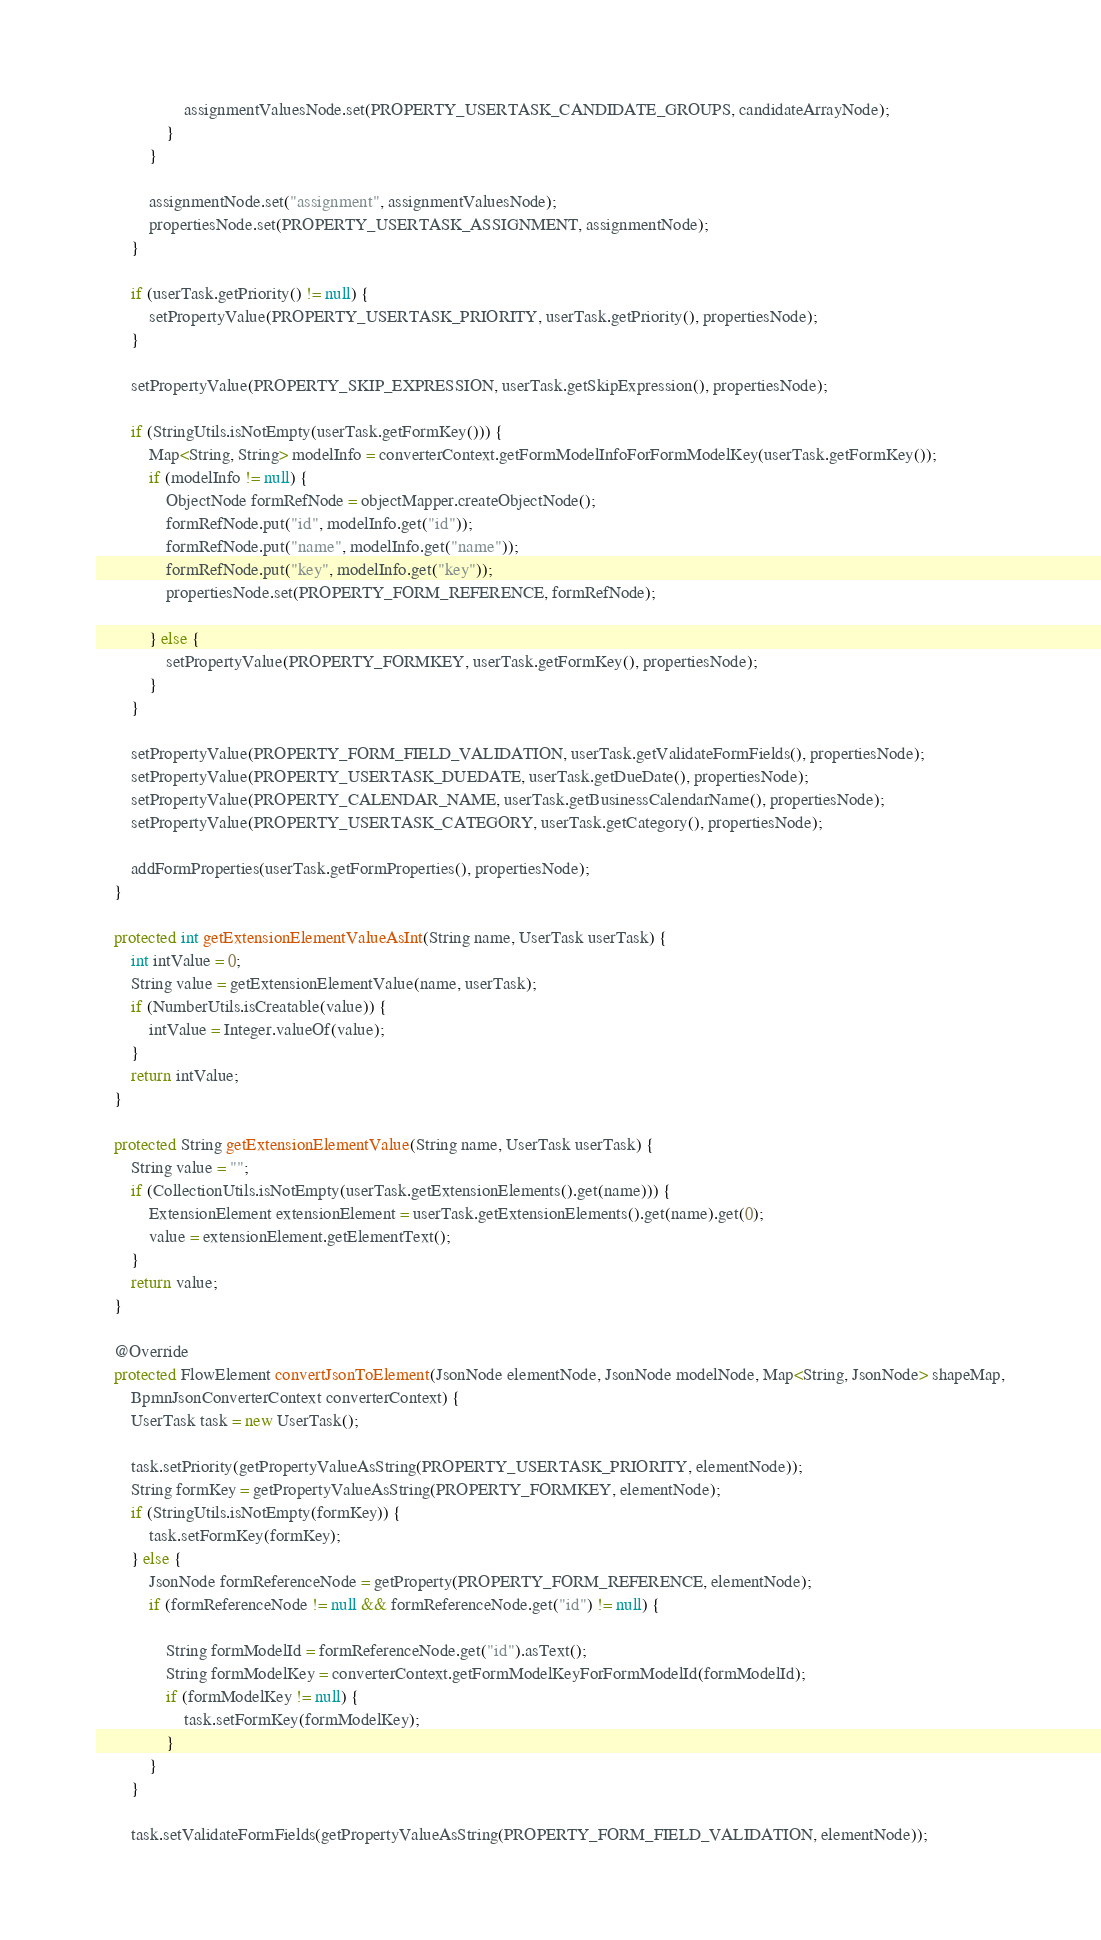<code> <loc_0><loc_0><loc_500><loc_500><_Java_>                    assignmentValuesNode.set(PROPERTY_USERTASK_CANDIDATE_GROUPS, candidateArrayNode);
                }
            }

            assignmentNode.set("assignment", assignmentValuesNode);
            propertiesNode.set(PROPERTY_USERTASK_ASSIGNMENT, assignmentNode);
        }

        if (userTask.getPriority() != null) {
            setPropertyValue(PROPERTY_USERTASK_PRIORITY, userTask.getPriority(), propertiesNode);
        }

        setPropertyValue(PROPERTY_SKIP_EXPRESSION, userTask.getSkipExpression(), propertiesNode);

        if (StringUtils.isNotEmpty(userTask.getFormKey())) {
            Map<String, String> modelInfo = converterContext.getFormModelInfoForFormModelKey(userTask.getFormKey());
            if (modelInfo != null) {
                ObjectNode formRefNode = objectMapper.createObjectNode();
                formRefNode.put("id", modelInfo.get("id"));
                formRefNode.put("name", modelInfo.get("name"));
                formRefNode.put("key", modelInfo.get("key"));
                propertiesNode.set(PROPERTY_FORM_REFERENCE, formRefNode);

            } else {
                setPropertyValue(PROPERTY_FORMKEY, userTask.getFormKey(), propertiesNode);
            }
        }

        setPropertyValue(PROPERTY_FORM_FIELD_VALIDATION, userTask.getValidateFormFields(), propertiesNode);
        setPropertyValue(PROPERTY_USERTASK_DUEDATE, userTask.getDueDate(), propertiesNode);
        setPropertyValue(PROPERTY_CALENDAR_NAME, userTask.getBusinessCalendarName(), propertiesNode);
        setPropertyValue(PROPERTY_USERTASK_CATEGORY, userTask.getCategory(), propertiesNode);

        addFormProperties(userTask.getFormProperties(), propertiesNode);
    }

    protected int getExtensionElementValueAsInt(String name, UserTask userTask) {
        int intValue = 0;
        String value = getExtensionElementValue(name, userTask);
        if (NumberUtils.isCreatable(value)) {
            intValue = Integer.valueOf(value);
        }
        return intValue;
    }

    protected String getExtensionElementValue(String name, UserTask userTask) {
        String value = "";
        if (CollectionUtils.isNotEmpty(userTask.getExtensionElements().get(name))) {
            ExtensionElement extensionElement = userTask.getExtensionElements().get(name).get(0);
            value = extensionElement.getElementText();
        }
        return value;
    }

    @Override
    protected FlowElement convertJsonToElement(JsonNode elementNode, JsonNode modelNode, Map<String, JsonNode> shapeMap,
        BpmnJsonConverterContext converterContext) {
        UserTask task = new UserTask();

        task.setPriority(getPropertyValueAsString(PROPERTY_USERTASK_PRIORITY, elementNode));
        String formKey = getPropertyValueAsString(PROPERTY_FORMKEY, elementNode);
        if (StringUtils.isNotEmpty(formKey)) {
            task.setFormKey(formKey);
        } else {
            JsonNode formReferenceNode = getProperty(PROPERTY_FORM_REFERENCE, elementNode);
            if (formReferenceNode != null && formReferenceNode.get("id") != null) {

                String formModelId = formReferenceNode.get("id").asText();
                String formModelKey = converterContext.getFormModelKeyForFormModelId(formModelId);
                if (formModelKey != null) {
                    task.setFormKey(formModelKey);
                }
            }
        }

        task.setValidateFormFields(getPropertyValueAsString(PROPERTY_FORM_FIELD_VALIDATION, elementNode));</code> 